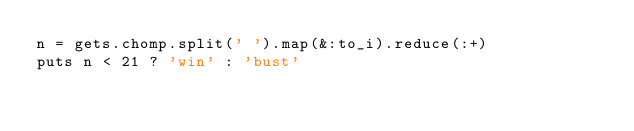<code> <loc_0><loc_0><loc_500><loc_500><_Ruby_>n = gets.chomp.split(' ').map(&:to_i).reduce(:+)
puts n < 21 ? 'win' : 'bust'</code> 